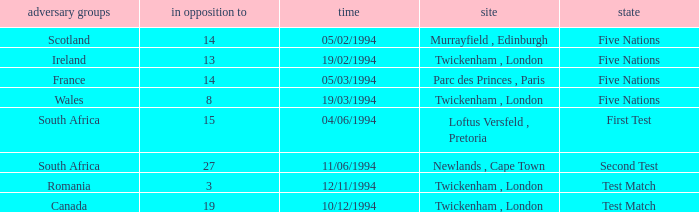Which venue has more than 19 against? Newlands , Cape Town. 